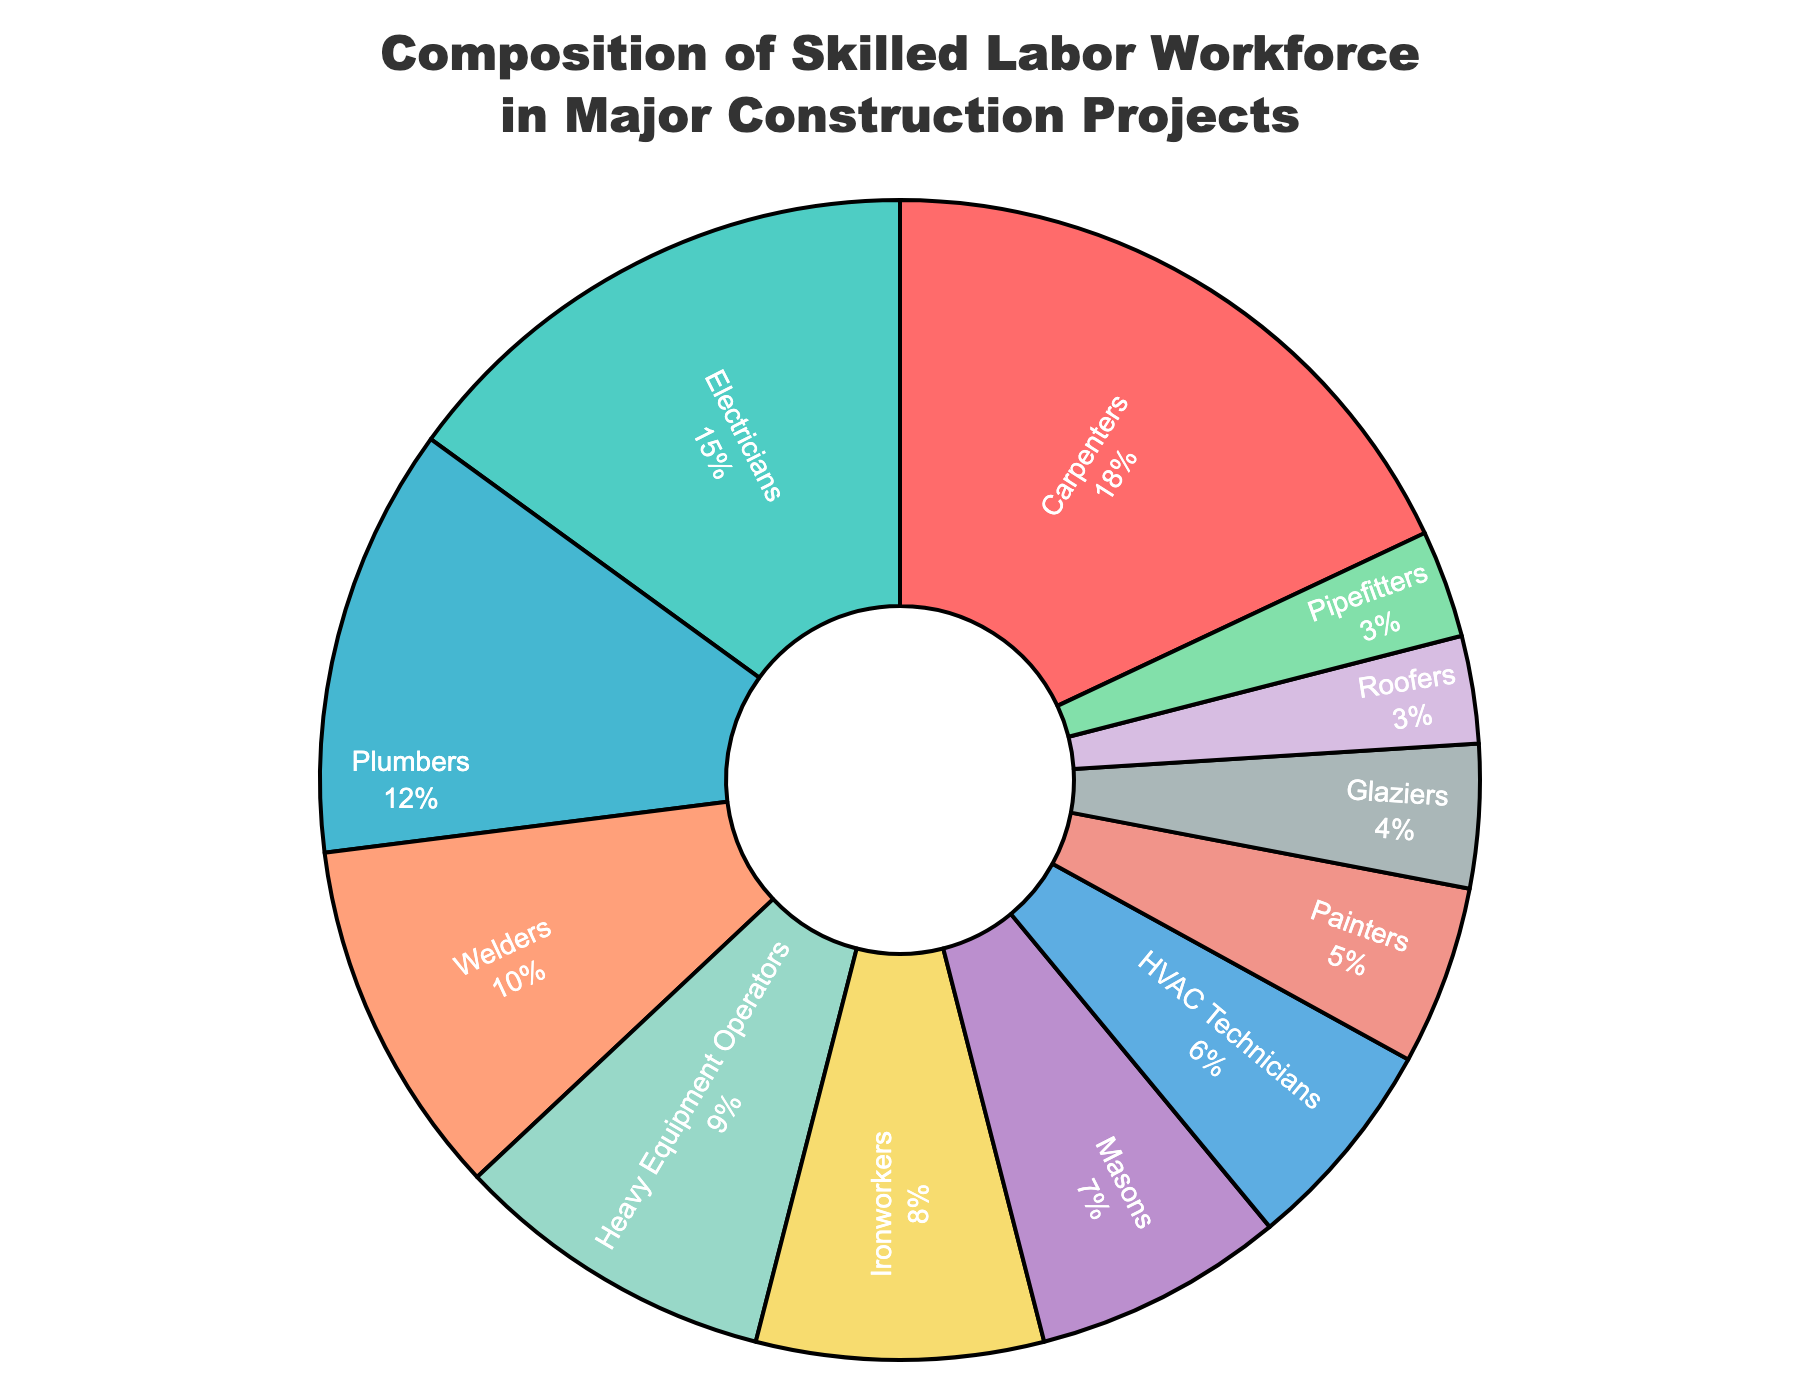What is the percentage of Plumbers in the workforce? Locate "Plumbers" in the pie chart and read the percentage directly next to their label.
Answer: 12% Which job categories have a higher percentage than Welders? List all job categories with a percentage greater than the 10% associated with Welders.
Answer: Carpenters, Electricians, Plumbers How much higher is the percentage of Carpenters compared to Glaziers? Subtract Glaziers' percentage (4%) from Carpenters' percentage (18%). 18% - 4% = 14%
Answer: 14% What are the job categories in the pie chart that make up less than 5% of the workforce each? Identify job categories whose percentages are less than 5% from the pie chart.
Answer: Glaziers, Roofers, Pipefitters How much combined percentage do Heavy Equipment Operators and Ironworkers contribute to the workforce? Add the percentages of Heavy Equipment Operators (9%) and Ironworkers (8%). 9% + 8% = 17%
Answer: 17% Which job category is the third largest in terms of percentage? Identify and rank the job categories by their percentages and find the third largest. After Carpenters and Electricians, it is Plumbers at 12%.
Answer: Plumbers What is the difference in percentage between the largest and smallest job categories? Subtract the smallest percentage (Roofers and Pipefitters at 3%) from the largest percentage (Carpenters at 18%). 18% - 3% = 15%
Answer: 15% How many job categories represent more than 10% each of the total workforce? Count all job categories with percentages greater than 10%. These are Carpenters, Electricians, and Plumbers.
Answer: 3 Which job category contributes the smallest percentage to the workforce? Identify the job category with the smallest segment in the pie chart, which has the smallest percentage.
Answer: Roofers and Pipefitters If you combine the percentages of Masons, HVAC Technicians, and Painters, what percentage of the total workforce do they represent? Add the percentages of Masons (7%), HVAC Technicians (6%), and Painters (5%). 7% + 6% + 5% = 18%
Answer: 18% 